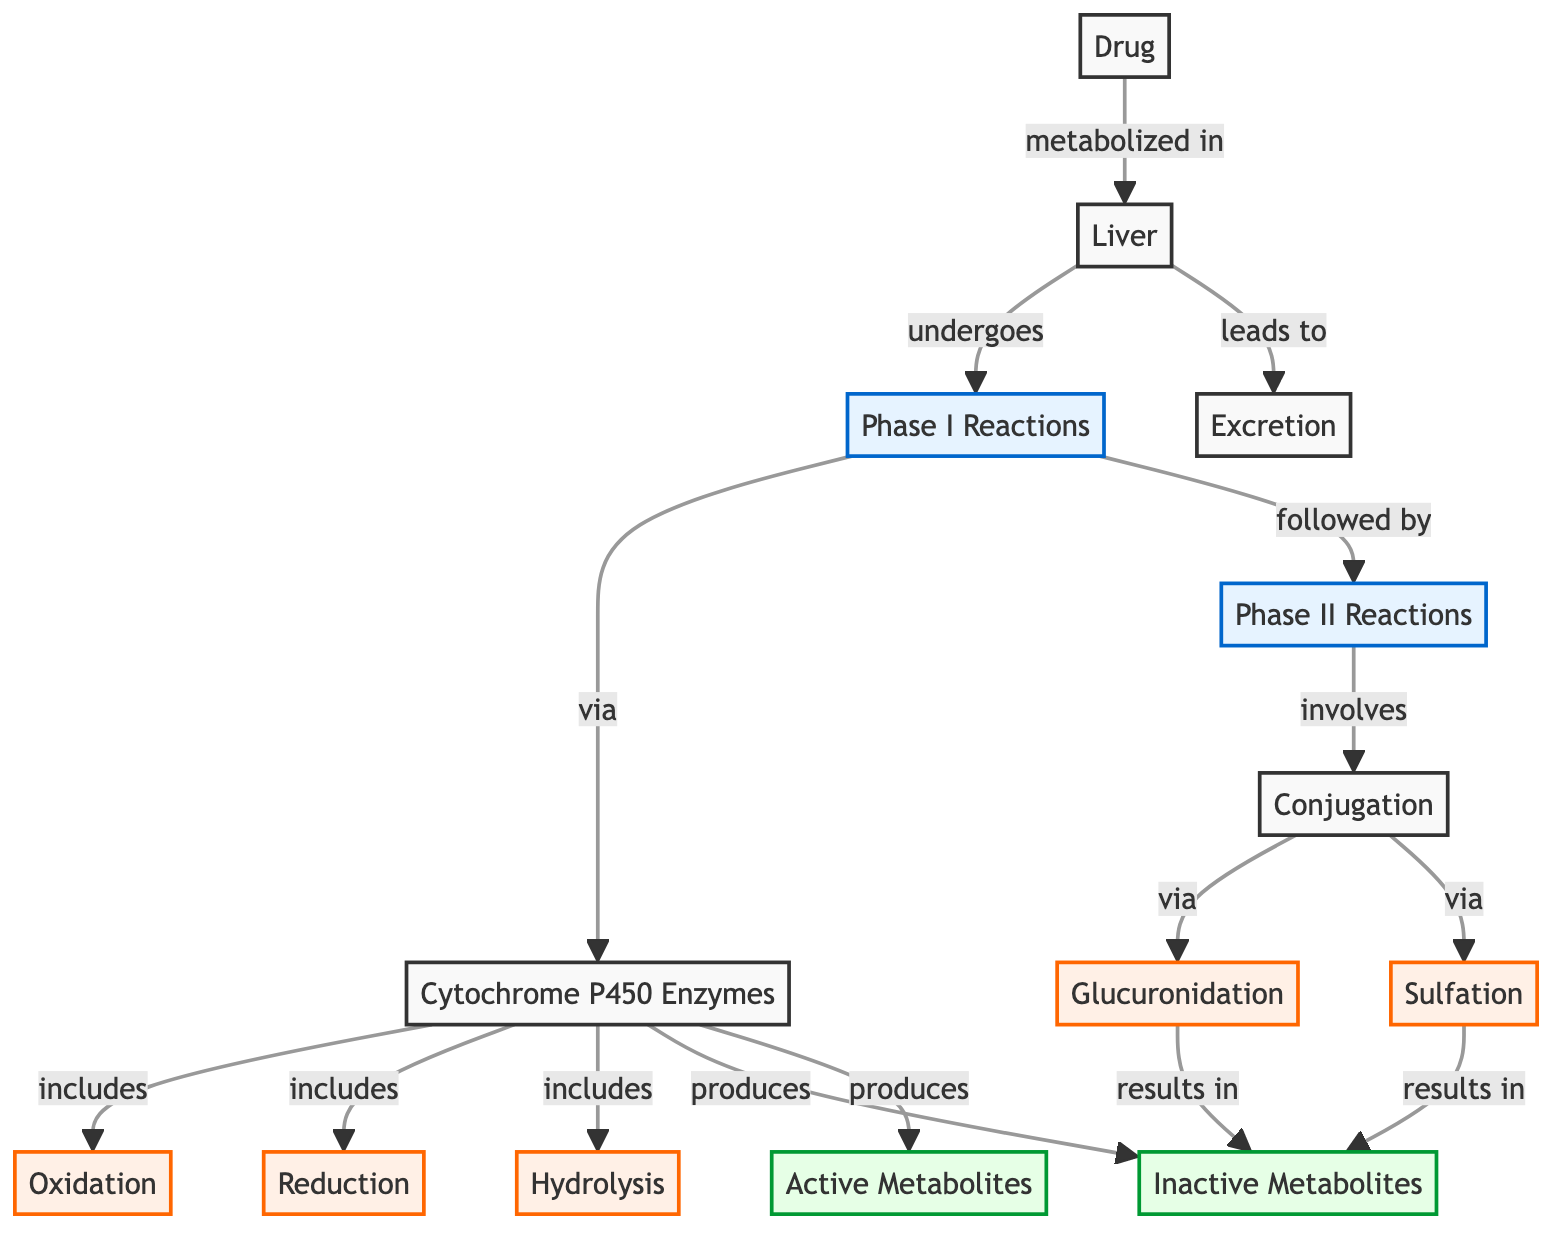What is the first phase of drug metabolism in the liver? The diagram indicates that the first phase of drug metabolism is "Phase I Reactions." It clearly labels this phase, showing that drug metabolism begins with this phase in the liver.
Answer: Phase I Reactions How many types of reactions are included in Phase I? In the diagram, Phase I Reactions are associated with three types of reactions: Oxidation, Reduction, and Hydrolysis. By counting these reactions, we find a total of three.
Answer: 3 Which enzyme is involved in Phase I Reactions? The diagram identifies "Cytochrome P450 Enzymes" as a component of Phase I Reactions. It is explicitly mentioned in the flow from Phase I to the types of reactions.
Answer: Cytochrome P450 Enzymes What do Phase II Reactions involve? The diagram indicates that Phase II Reactions involve "Conjugation." It specifically connects Phase II to this process, implying it is a distinct contributing factor in drug metabolism after Phase I.
Answer: Conjugation What results from Glucuronidation? According to the diagram, Glucuronidation results in "Inactive Metabolites." This connection helps to understand the outcome of this specific reaction in the drug metabolism pathway.
Answer: Inactive Metabolites How many metabolites are produced in the diagram? The diagram shows two types of metabolites produced: "Inactive Metabolites" and "Active Metabolites." Counting these gives us a total of two distinct metabolite outcomes from the pathways.
Answer: 2 What is the final step mentioned after drug metabolism? The diagram shows that after drug metabolism in the liver, the process leads to "Excretion." This is the final step indicated and represents the removal of substances from the body.
Answer: Excretion How do Phase I reactions lead to active metabolites? The diagram illustrates that Phase I reactions, particularly through the processes listed, produce "Active Metabolites." This indicates that certain reactions directly contribute to creating these active forms.
Answer: Active Metabolites 